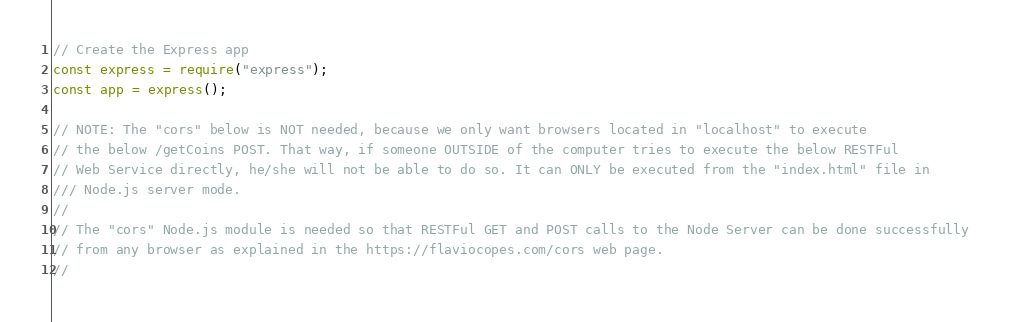<code> <loc_0><loc_0><loc_500><loc_500><_JavaScript_>// Create the Express app
const express = require("express");
const app = express();

// NOTE: The "cors" below is NOT needed, because we only want browsers located in "localhost" to execute
// the below /getCoins POST. That way, if someone OUTSIDE of the computer tries to execute the below RESTFul
// Web Service directly, he/she will not be able to do so. It can ONLY be executed from the "index.html" file in
/// Node.js server mode.
//
// The "cors" Node.js module is needed so that RESTFul GET and POST calls to the Node Server can be done successfully
// from any browser as explained in the https://flaviocopes.com/cors web page.
//</code> 